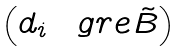Convert formula to latex. <formula><loc_0><loc_0><loc_500><loc_500>\begin{pmatrix} d _ { i } & \ g r e \tilde { B } \end{pmatrix}</formula> 